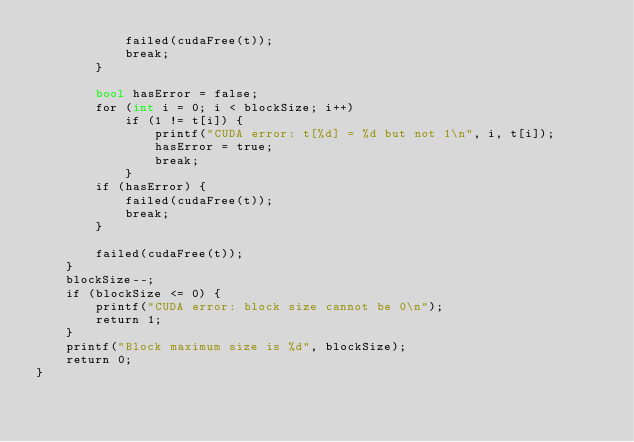<code> <loc_0><loc_0><loc_500><loc_500><_Cuda_>            failed(cudaFree(t));
            break;
        }

        bool hasError = false;
        for (int i = 0; i < blockSize; i++)
            if (1 != t[i]) {
                printf("CUDA error: t[%d] = %d but not 1\n", i, t[i]);
                hasError = true;
                break;
            }
        if (hasError) {
            failed(cudaFree(t));
            break;
        }

        failed(cudaFree(t));
    }
    blockSize--;
    if (blockSize <= 0) {
        printf("CUDA error: block size cannot be 0\n");
        return 1;
    }
    printf("Block maximum size is %d", blockSize);
    return 0;
}</code> 